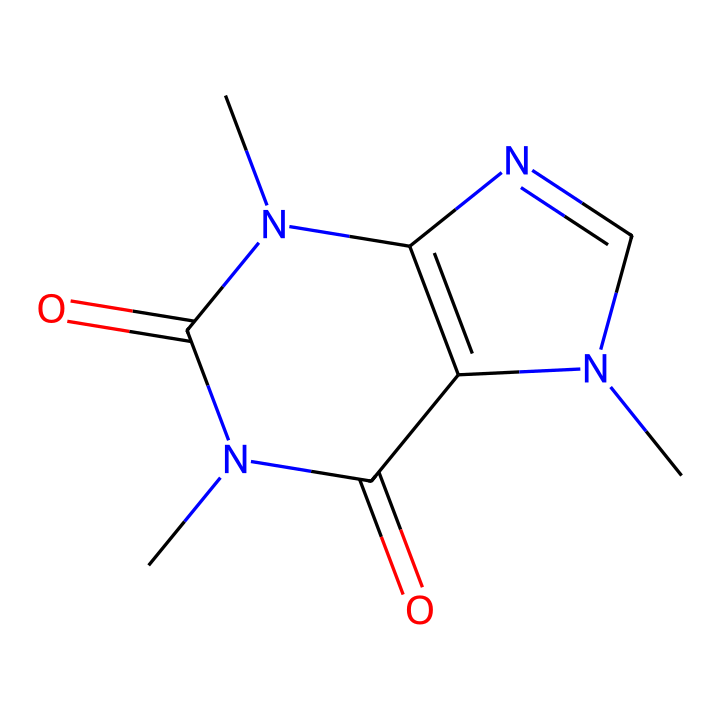What is the molecular formula of caffeine? Analyzing the provided SMILES structure, we identify that there are 8 carbon (C) atoms, 10 hydrogen (H) atoms, 4 nitrogen (N) atoms, and 2 oxygen (O) atoms. The molecular formula is derived by counting these atoms.
Answer: C8H10N4O2 How many nitrogen atoms are in caffeine? In the SMILES representation, each "N" indicates a nitrogen atom. There are 4 occurrences of "N" in the structure, indicating the total count of nitrogen atoms.
Answer: 4 What is the type of functional groups present in caffeine? Caffeine contains amine groups (due to the nitrogen atoms) and carbonyl groups (indicated by the carbon double-bonded to oxygen). Looking for functional groups in the structure leads to this conclusion.
Answer: amine and carbonyl What type of chemical compound is caffeine? Based on the structure and presence of nitrogen atoms in a heterocyclic arrangement, caffeine is classified as an alkaloid. This classification is due to its structure containing rings and nitrogen, which are typical characteristics of alkaloids.
Answer: alkaloid What is the total number of rings in the caffeine structure? By analyzing the structure, we observe that caffeine has 2 fused rings. This can be determined by tracing the connections in the structure that create circular arrangements.
Answer: 2 What is the common source of caffeine in energy drinks? Caffeine is commonly extracted from sources like coffee beans, tea leaves, and cola nuts. These natural sources typically provide caffeine for energy drinks, and they can be identified based on standard knowledge of caffeine sources.
Answer: coffee beans 